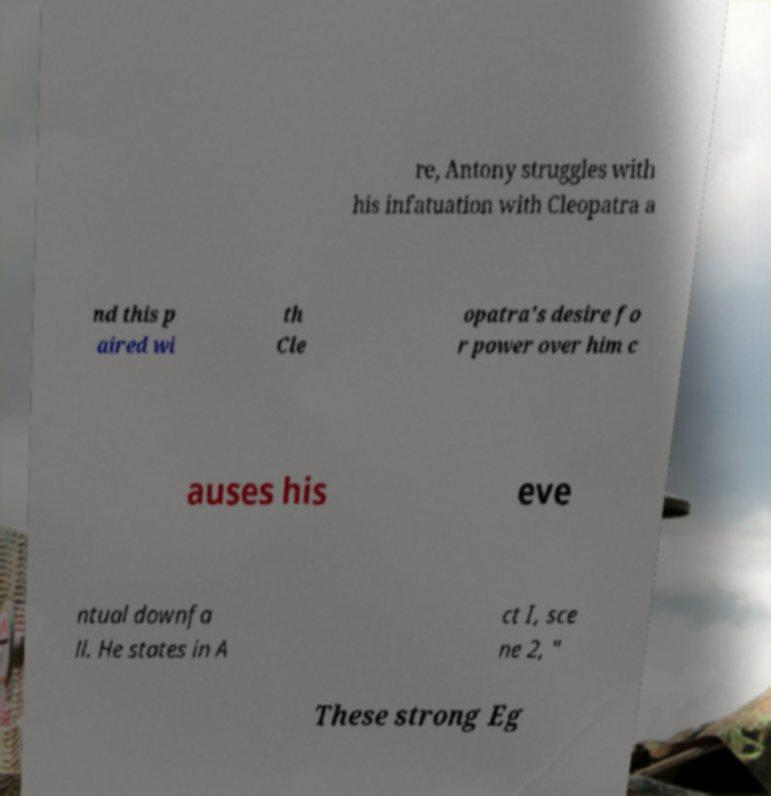Could you extract and type out the text from this image? re, Antony struggles with his infatuation with Cleopatra a nd this p aired wi th Cle opatra's desire fo r power over him c auses his eve ntual downfa ll. He states in A ct I, sce ne 2, " These strong Eg 